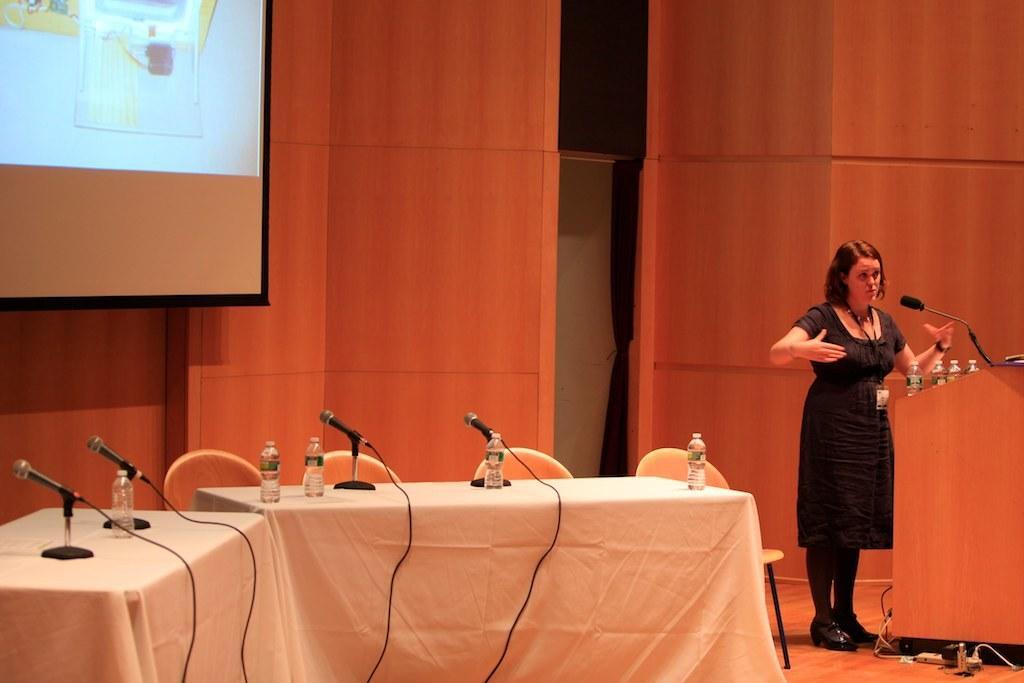Could you give a brief overview of what you see in this image? In this image, we can see a person wearing clothes and standing in front of the podium. There are bottles and mic on the right side of the image. There are tables at the bottom of the image covered with a cloth. These tables contains bottles and mics. There are chairs in the middle of the image. There is a screen in the top left of the image. 